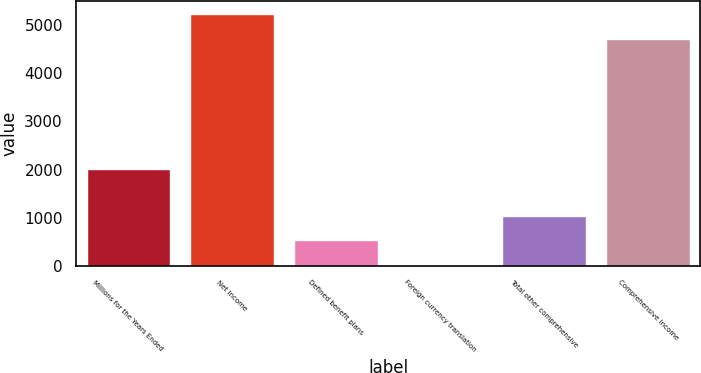Convert chart to OTSL. <chart><loc_0><loc_0><loc_500><loc_500><bar_chart><fcel>Millions for the Years Ended<fcel>Net income<fcel>Defined benefit plans<fcel>Foreign currency translation<fcel>Total other comprehensive<fcel>Comprehensive income<nl><fcel>2014<fcel>5236.8<fcel>528.8<fcel>12<fcel>1045.6<fcel>4720<nl></chart> 